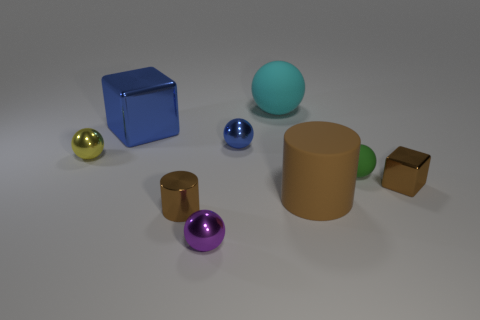Add 1 big rubber balls. How many objects exist? 10 Subtract all cyan balls. How many balls are left? 4 Subtract 2 balls. How many balls are left? 3 Subtract all blocks. How many objects are left? 7 Add 7 small metal cylinders. How many small metal cylinders are left? 8 Add 6 brown metal blocks. How many brown metal blocks exist? 7 Subtract all brown cubes. How many cubes are left? 1 Subtract 1 cyan spheres. How many objects are left? 8 Subtract all cyan cylinders. Subtract all green spheres. How many cylinders are left? 2 Subtract all purple blocks. How many yellow spheres are left? 1 